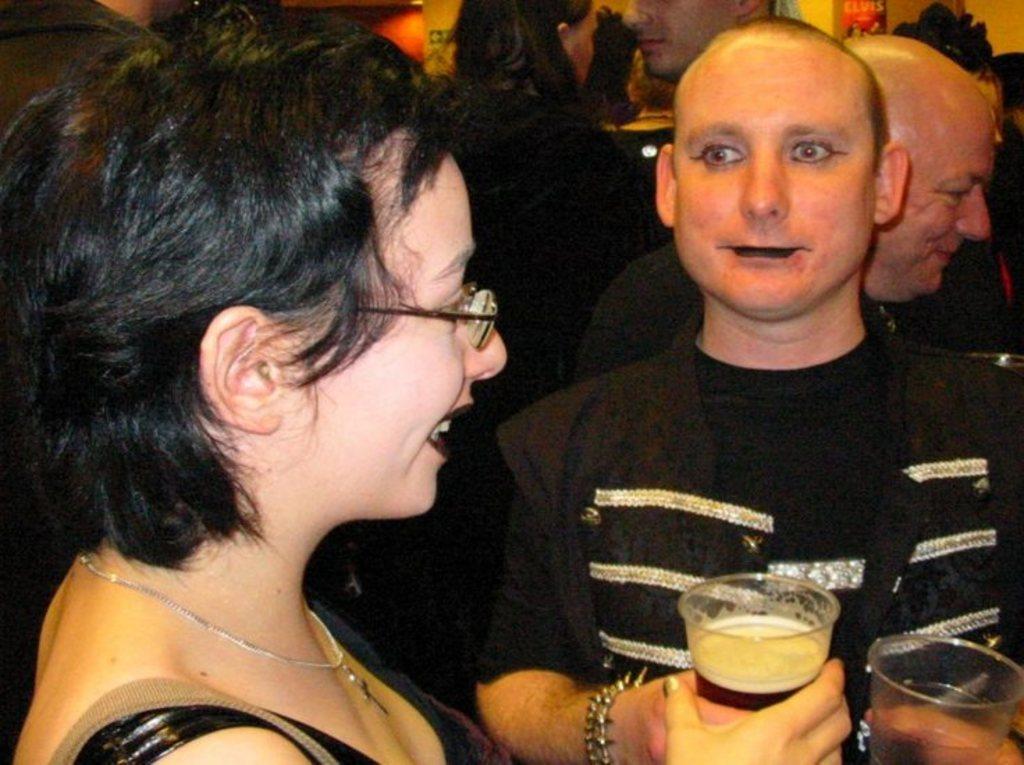In one or two sentences, can you explain what this image depicts? In the left a woman is holding a wine glass in her hand and in the right a man is standing looking at this woman. 